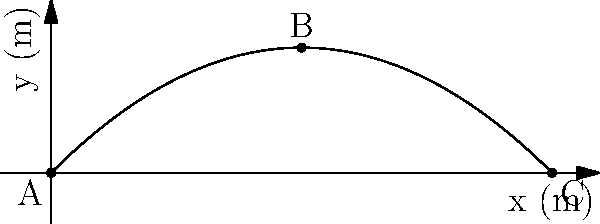A projectile is launched from point A with an initial velocity of 50 m/s at an angle of 45° above the horizontal. Calculate the velocity of the projectile at point B (the highest point of the trajectory) and point C (the landing point). How does the magnitude of the velocity at these points compare to the initial velocity? Let's approach this step-by-step:

1) Initial velocity components:
   $v_{0x} = v_0 \cos \theta = 50 \cos 45° = 35.36$ m/s
   $v_{0y} = v_0 \sin \theta = 50 \sin 45° = 35.36$ m/s

2) At point B (highest point):
   - Vertical velocity $v_y = 0$ (at the peak)
   - Horizontal velocity $v_x = v_{0x} = 35.36$ m/s (constant throughout flight)
   - Velocity at B: $v_B = \sqrt{v_x^2 + v_y^2} = 35.36$ m/s

3) At point C (landing point):
   - Vertical velocity $v_y = -v_{0y} = -35.36$ m/s (symmetric to launch)
   - Horizontal velocity $v_x = v_{0x} = 35.36$ m/s
   - Velocity at C: $v_C = \sqrt{v_x^2 + v_y^2} = \sqrt{35.36^2 + 35.36^2} = 50$ m/s

4) Comparison:
   - At B: $v_B = 35.36$ m/s, which is $\frac{35.36}{50} = 0.707$ times the initial velocity
   - At C: $v_C = 50$ m/s, which is equal to the initial velocity

The magnitude of velocity at the highest point (B) is less than the initial velocity, while at the landing point (C), it's equal to the initial velocity.
Answer: B: 35.36 m/s (0.707v₀), C: 50 m/s (v₀) 